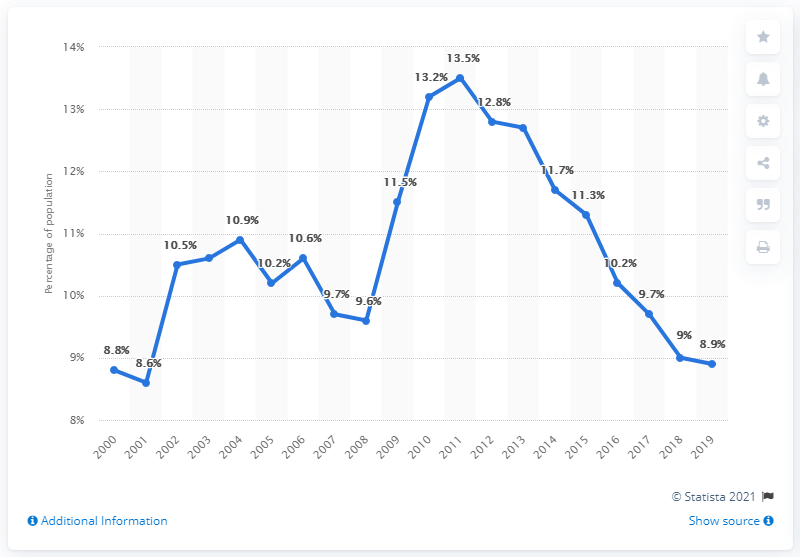Indicate a few pertinent items in this graphic. In 2018 and 2019, the population's sum total percentage was 17.9%. In 2017, the population was approximately 9.7%. 